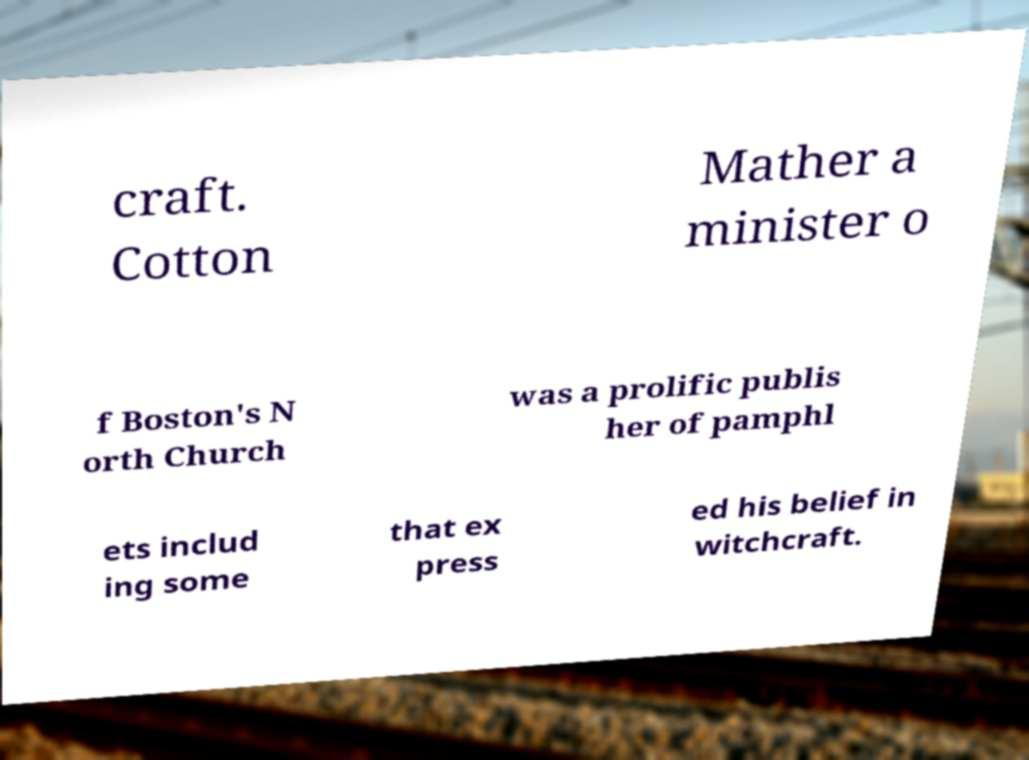What messages or text are displayed in this image? I need them in a readable, typed format. craft. Cotton Mather a minister o f Boston's N orth Church was a prolific publis her of pamphl ets includ ing some that ex press ed his belief in witchcraft. 